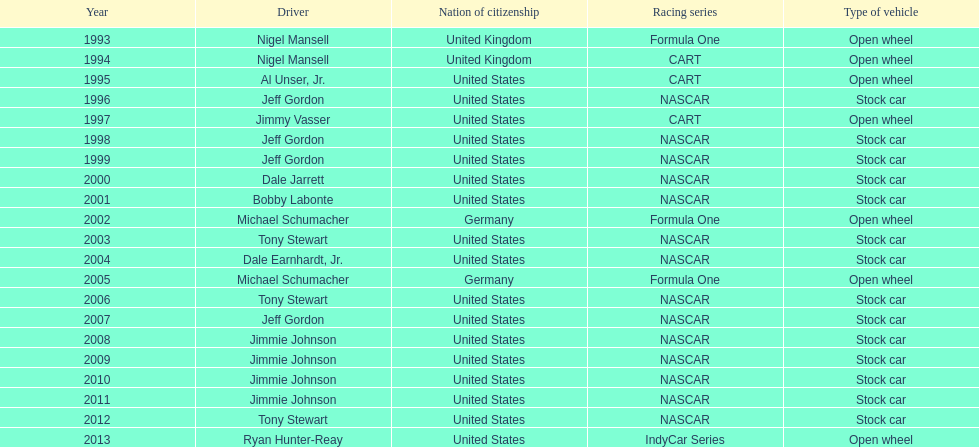How many total row entries are there? 21. 